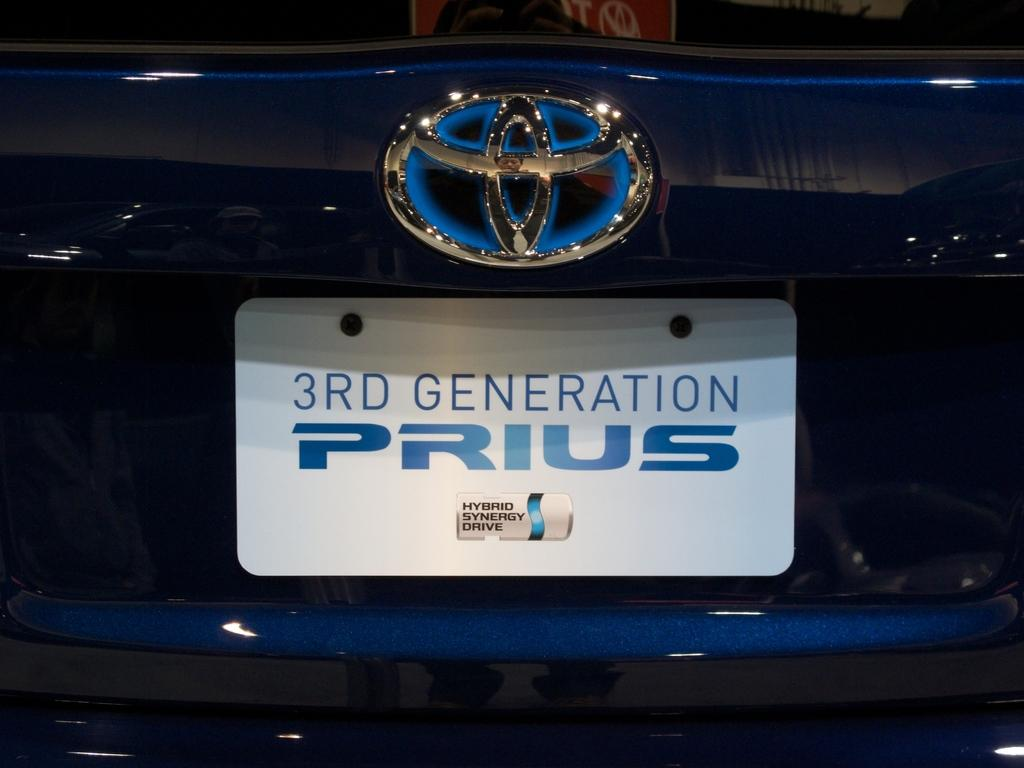Provide a one-sentence caption for the provided image. the emblem and licences plate of a toyota prius. 